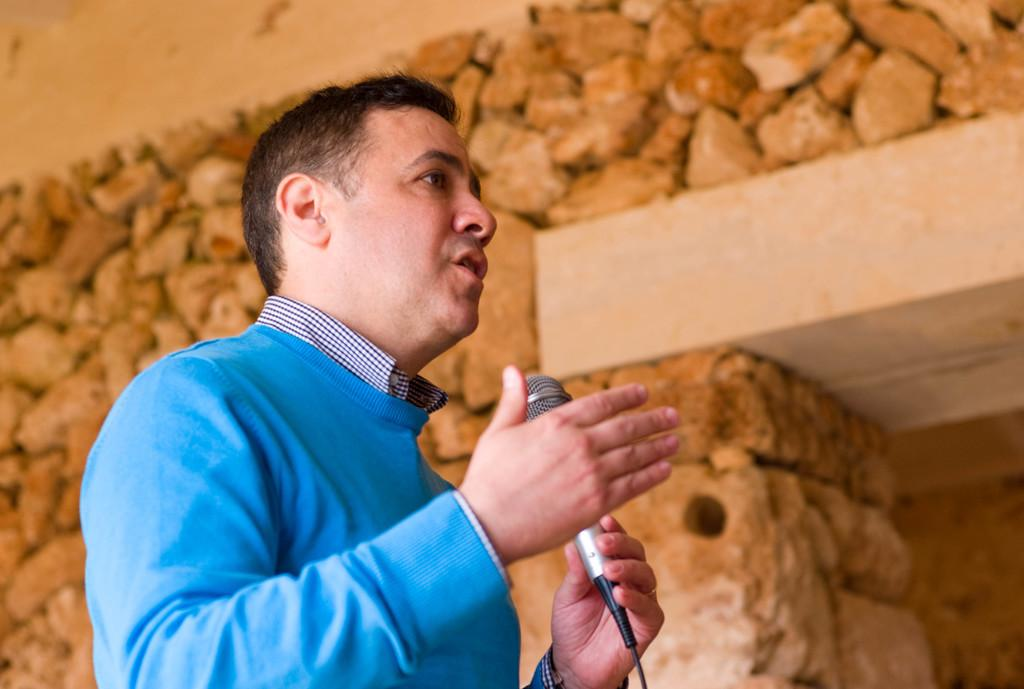What is the main subject of the image? There is a person in the image. What is the person holding in the image? The person is holding a microphone. What is the person doing with the microphone? The person is talking. What type of canvas is visible in the image? There is no canvas present in the image. What color is the gold object in the image? There is no gold object present in the image. 